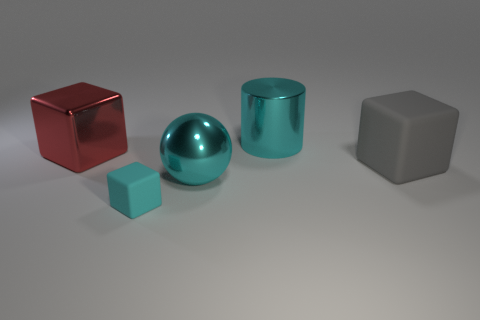Add 1 big metallic things. How many objects exist? 6 Subtract all big metal cubes. How many cubes are left? 2 Subtract 1 balls. How many balls are left? 0 Subtract all cyan cubes. How many cubes are left? 2 Subtract all cubes. How many objects are left? 2 Add 3 big gray objects. How many big gray objects are left? 4 Add 2 small red rubber cylinders. How many small red rubber cylinders exist? 2 Subtract 1 cyan cubes. How many objects are left? 4 Subtract all red cylinders. Subtract all red blocks. How many cylinders are left? 1 Subtract all purple cylinders. How many brown blocks are left? 0 